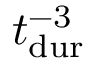<formula> <loc_0><loc_0><loc_500><loc_500>{ t _ { d u r } } ^ { - 3 }</formula> 